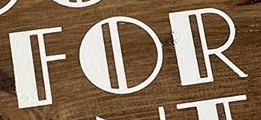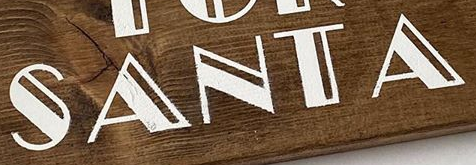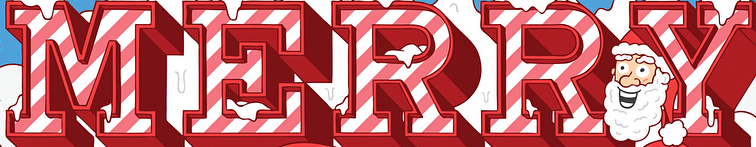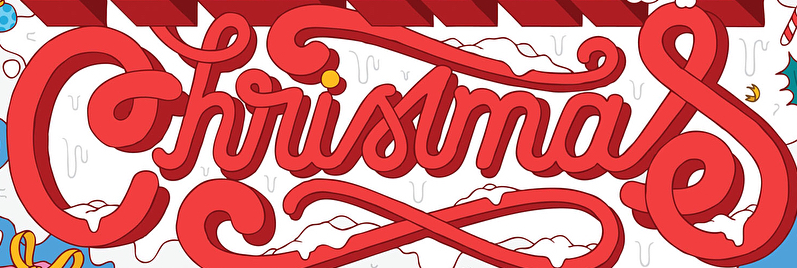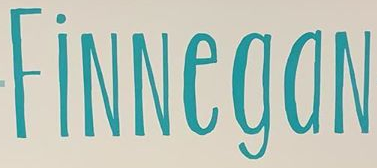Identify the words shown in these images in order, separated by a semicolon. FOR; SANTA; MERRY; Christmas; FiNNegaN 